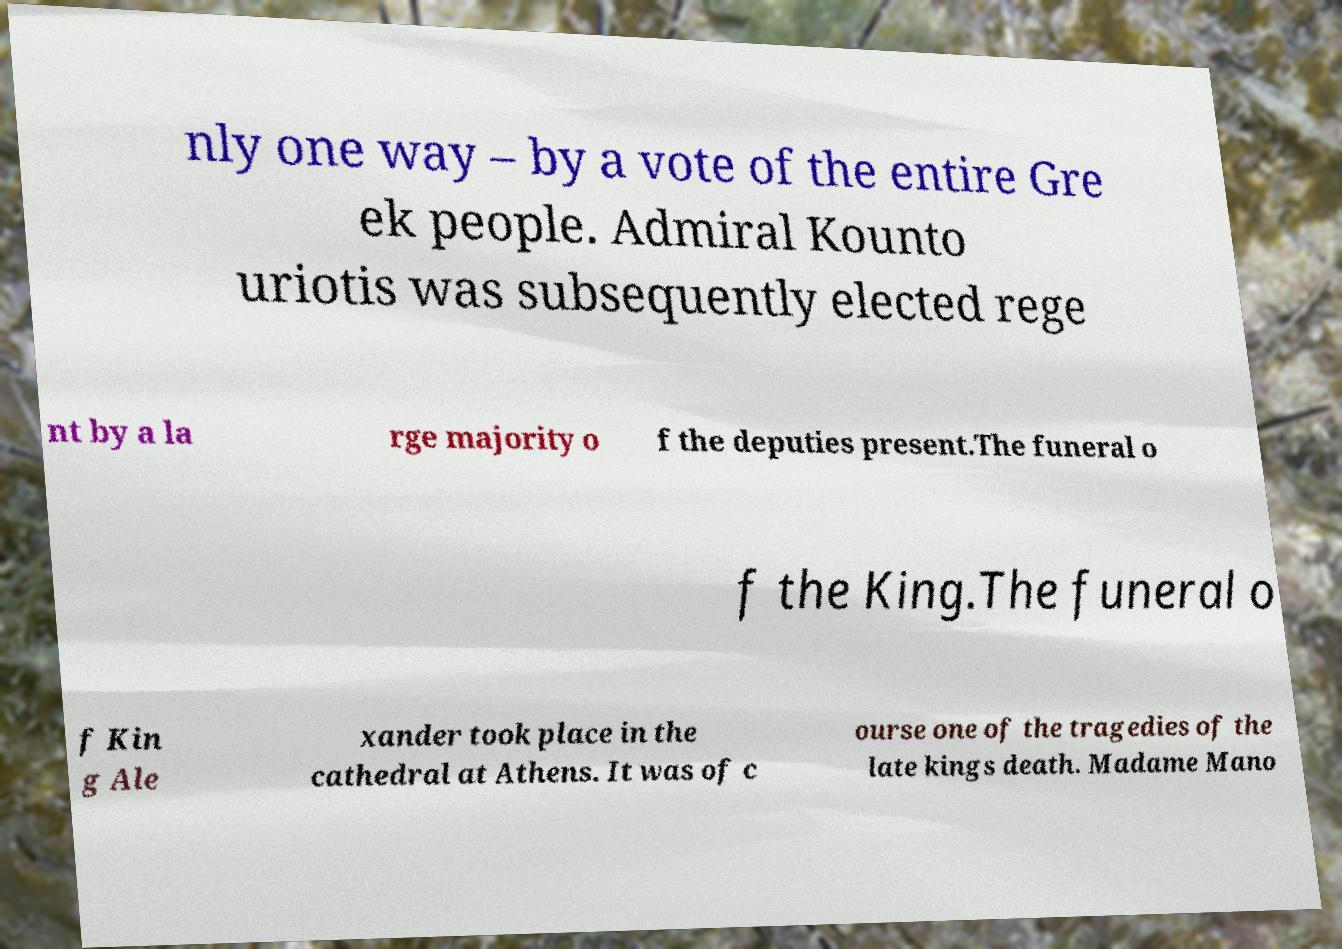Please read and relay the text visible in this image. What does it say? nly one way – by a vote of the entire Gre ek people. Admiral Kounto uriotis was subsequently elected rege nt by a la rge majority o f the deputies present.The funeral o f the King.The funeral o f Kin g Ale xander took place in the cathedral at Athens. It was of c ourse one of the tragedies of the late kings death. Madame Mano 